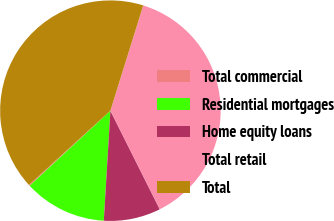Convert chart to OTSL. <chart><loc_0><loc_0><loc_500><loc_500><pie_chart><fcel>Total commercial<fcel>Residential mortgages<fcel>Home equity loans<fcel>Total retail<fcel>Total<nl><fcel>0.16%<fcel>12.12%<fcel>8.34%<fcel>37.79%<fcel>41.57%<nl></chart> 